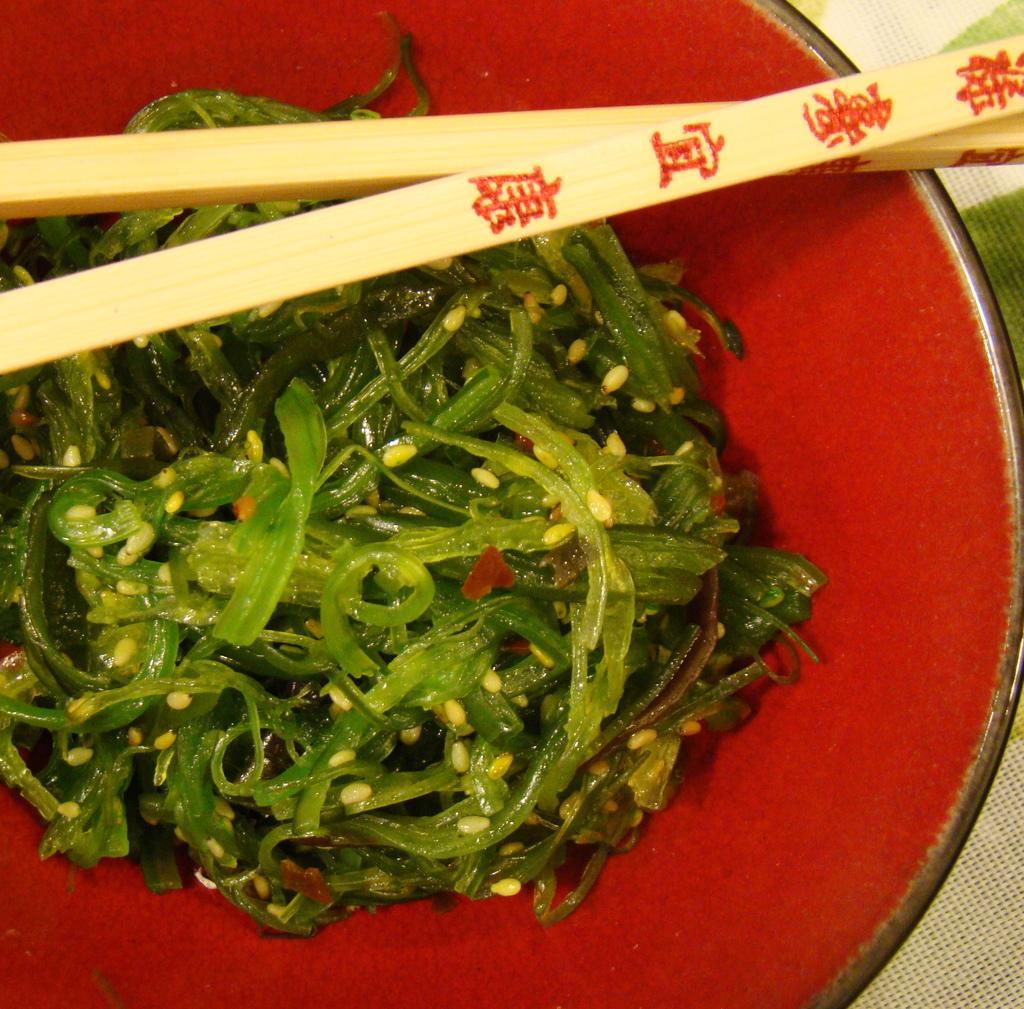Please provide a concise description of this image. There is some food in the bowl and these are chopsticks. 